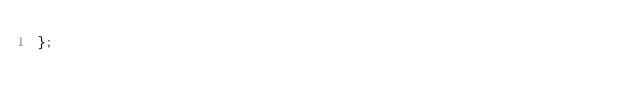Convert code to text. <code><loc_0><loc_0><loc_500><loc_500><_TypeScript_>};
</code> 